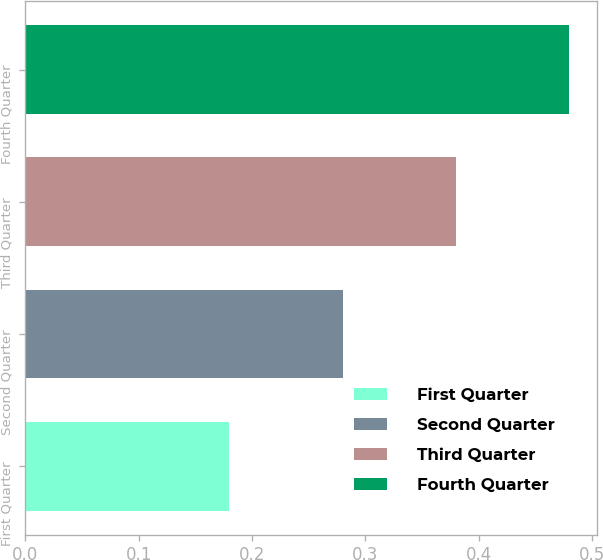Convert chart to OTSL. <chart><loc_0><loc_0><loc_500><loc_500><bar_chart><fcel>First Quarter<fcel>Second Quarter<fcel>Third Quarter<fcel>Fourth Quarter<nl><fcel>0.18<fcel>0.28<fcel>0.38<fcel>0.48<nl></chart> 